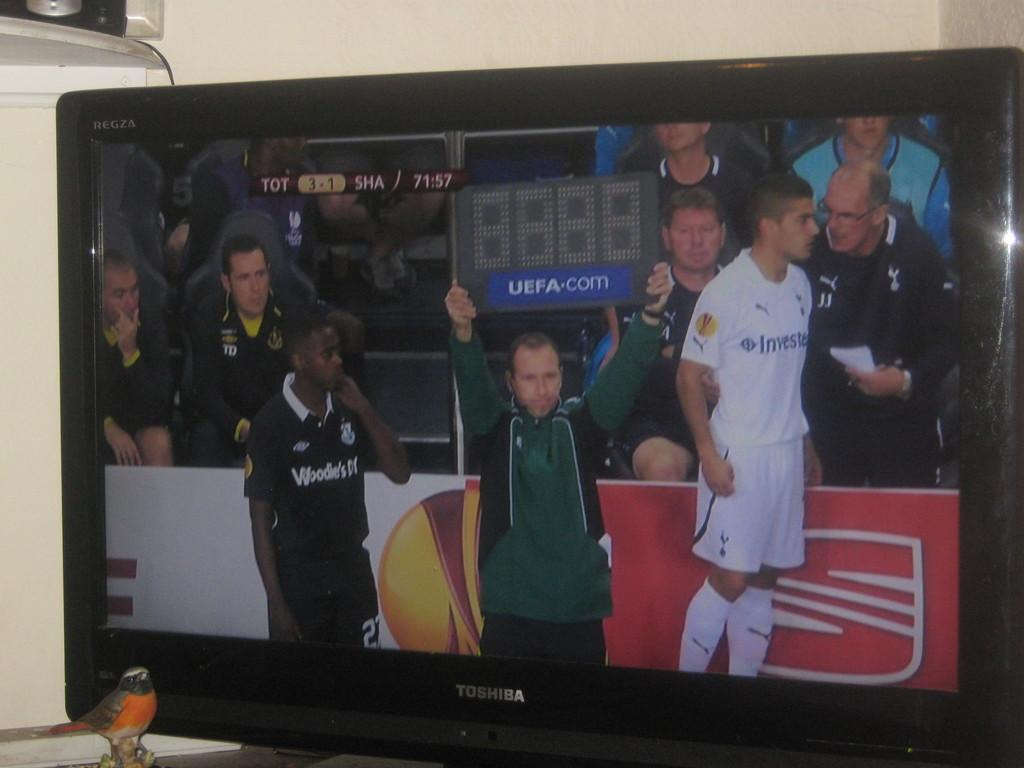<image>
Offer a succinct explanation of the picture presented. A man on TV holds a sign that says UEFA.com on it. 